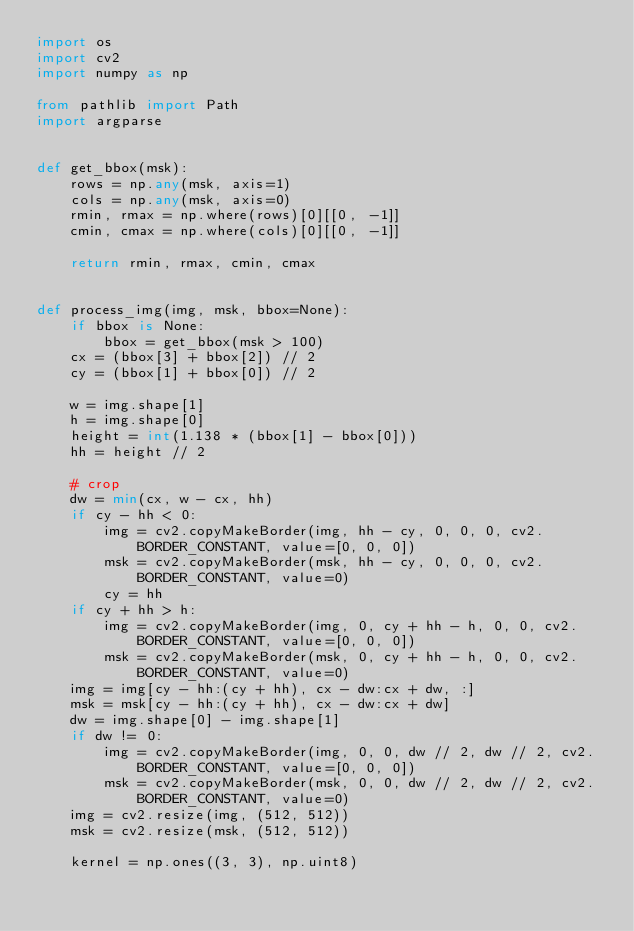<code> <loc_0><loc_0><loc_500><loc_500><_Python_>import os
import cv2
import numpy as np

from pathlib import Path
import argparse


def get_bbox(msk):
    rows = np.any(msk, axis=1)
    cols = np.any(msk, axis=0)
    rmin, rmax = np.where(rows)[0][[0, -1]]
    cmin, cmax = np.where(cols)[0][[0, -1]]

    return rmin, rmax, cmin, cmax


def process_img(img, msk, bbox=None):
    if bbox is None:
        bbox = get_bbox(msk > 100)
    cx = (bbox[3] + bbox[2]) // 2
    cy = (bbox[1] + bbox[0]) // 2

    w = img.shape[1]
    h = img.shape[0]
    height = int(1.138 * (bbox[1] - bbox[0]))
    hh = height // 2

    # crop
    dw = min(cx, w - cx, hh)
    if cy - hh < 0:
        img = cv2.copyMakeBorder(img, hh - cy, 0, 0, 0, cv2.BORDER_CONSTANT, value=[0, 0, 0])
        msk = cv2.copyMakeBorder(msk, hh - cy, 0, 0, 0, cv2.BORDER_CONSTANT, value=0)
        cy = hh
    if cy + hh > h:
        img = cv2.copyMakeBorder(img, 0, cy + hh - h, 0, 0, cv2.BORDER_CONSTANT, value=[0, 0, 0])
        msk = cv2.copyMakeBorder(msk, 0, cy + hh - h, 0, 0, cv2.BORDER_CONSTANT, value=0)
    img = img[cy - hh:(cy + hh), cx - dw:cx + dw, :]
    msk = msk[cy - hh:(cy + hh), cx - dw:cx + dw]
    dw = img.shape[0] - img.shape[1]
    if dw != 0:
        img = cv2.copyMakeBorder(img, 0, 0, dw // 2, dw // 2, cv2.BORDER_CONSTANT, value=[0, 0, 0])
        msk = cv2.copyMakeBorder(msk, 0, 0, dw // 2, dw // 2, cv2.BORDER_CONSTANT, value=0)
    img = cv2.resize(img, (512, 512))
    msk = cv2.resize(msk, (512, 512))

    kernel = np.ones((3, 3), np.uint8)</code> 